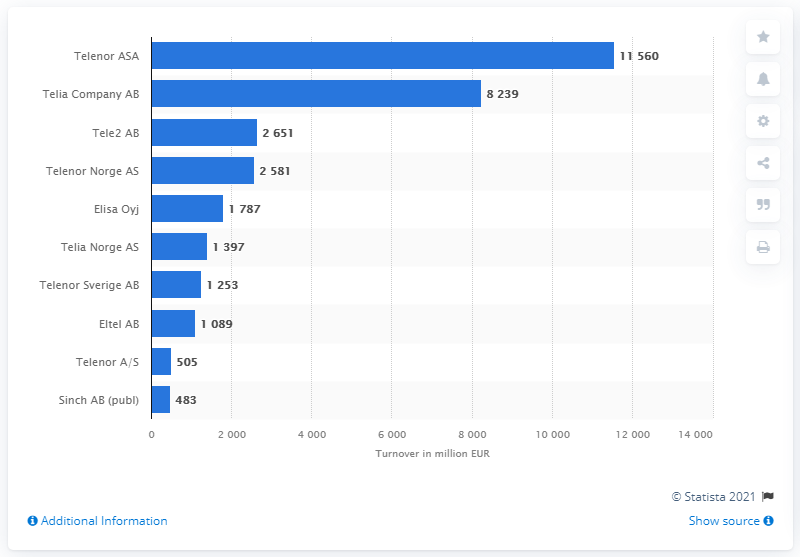List a handful of essential elements in this visual. According to a recent survey, Telia Company AB ranked second in the Nordic countries in terms of turnover, following another company. As of June 2021, Telenor ASA was the leading telecommunication company in the Nordic countries in terms of turnover. Telenor ASA's turnover in June 2021 was approximately 11,560. 